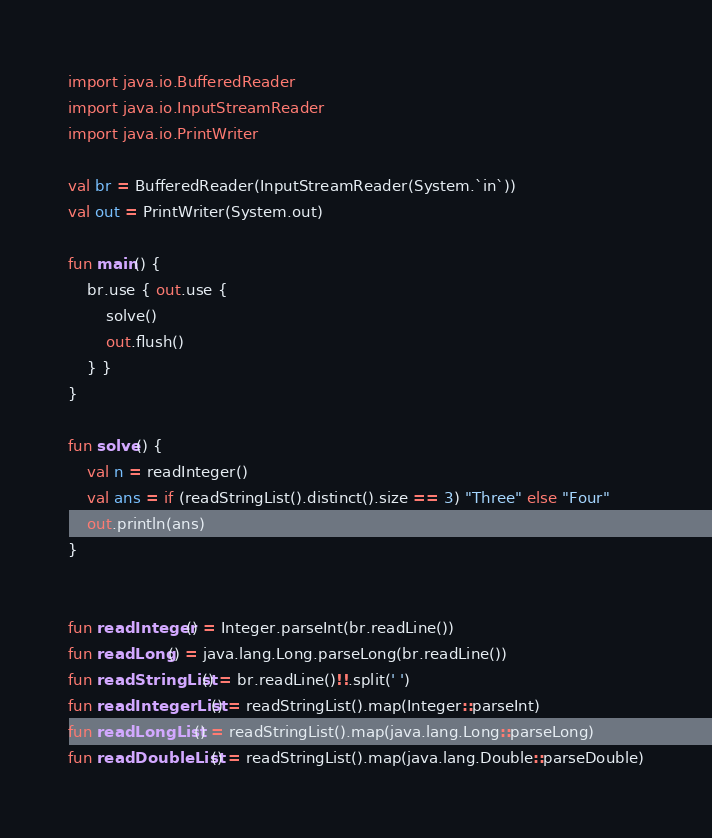<code> <loc_0><loc_0><loc_500><loc_500><_Kotlin_>import java.io.BufferedReader
import java.io.InputStreamReader
import java.io.PrintWriter

val br = BufferedReader(InputStreamReader(System.`in`))
val out = PrintWriter(System.out)

fun main() {
    br.use { out.use {
        solve()
        out.flush()
    } }
}

fun solve() {
    val n = readInteger()
    val ans = if (readStringList().distinct().size == 3) "Three" else "Four"
    out.println(ans)
}


fun readInteger() = Integer.parseInt(br.readLine())
fun readLong() = java.lang.Long.parseLong(br.readLine())
fun readStringList() = br.readLine()!!.split(' ')
fun readIntegerList() = readStringList().map(Integer::parseInt)
fun readLongList() = readStringList().map(java.lang.Long::parseLong)
fun readDoubleList() = readStringList().map(java.lang.Double::parseDouble)
</code> 